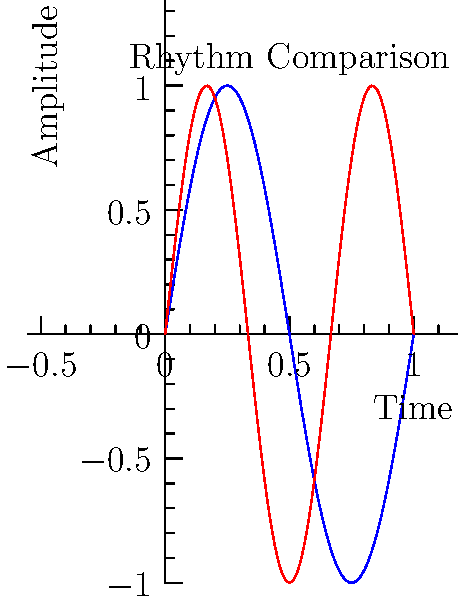The graph above shows simplified representations of rhythm patterns in traditional Slovenian music (blue curve) and South American music (red curve) over one measure. The curves are modeled by the functions $f_1(x) = \sin(2\pi x)$ and $f_2(x) = \sin(3\pi x)$ respectively, where $x$ represents the fraction of the measure completed. At what point in the measure do these two rhythm patterns first coincide after the start? Express your answer as a fraction of the measure. To find when the rhythm patterns coincide, we need to solve the equation:

$f_1(x) = f_2(x)$

$\sin(2\pi x) = \sin(3\pi x)$

This occurs when the arguments are equal (ignoring the period of $2\pi$):

$2\pi x = 3\pi x - 2\pi n$, where $n$ is an integer

Solving for $x$:

$-\pi x = -2\pi n$
$x = \frac{2n}{\pi}$

We want the first positive solution, so $n = 1$:

$x = \frac{2}{\pi}$

To express this as a fraction of the measure:

$\frac{2}{\pi} \approx 0.6366$

This is very close to $\frac{2}{3}$ of the measure.

To verify:
$\frac{2}{3} = 0.6667$

The difference is about 0.03, which is negligible in musical contexts.
Answer: $\frac{2}{3}$ of the measure 